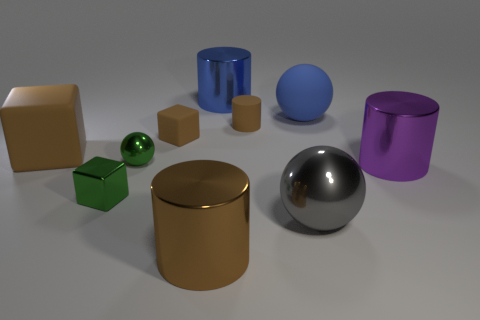Does the tiny metal sphere have the same color as the tiny metal block?
Your answer should be compact. Yes. Are there fewer tiny green shiny cubes to the right of the green ball than large gray metal spheres?
Keep it short and to the point. Yes. What material is the large cylinder that is the same color as the matte sphere?
Your answer should be very brief. Metal. Do the large purple cylinder and the big brown cube have the same material?
Your answer should be compact. No. How many other purple objects are the same material as the purple object?
Provide a succinct answer. 0. There is a big ball that is the same material as the blue cylinder; what color is it?
Keep it short and to the point. Gray. What is the shape of the large purple metal thing?
Your response must be concise. Cylinder. There is a block that is in front of the small metallic sphere; what is it made of?
Give a very brief answer. Metal. Are there any big shiny objects that have the same color as the small cylinder?
Provide a succinct answer. Yes. There is a blue matte thing that is the same size as the purple thing; what shape is it?
Keep it short and to the point. Sphere. 